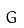<formula> <loc_0><loc_0><loc_500><loc_500>G</formula> 